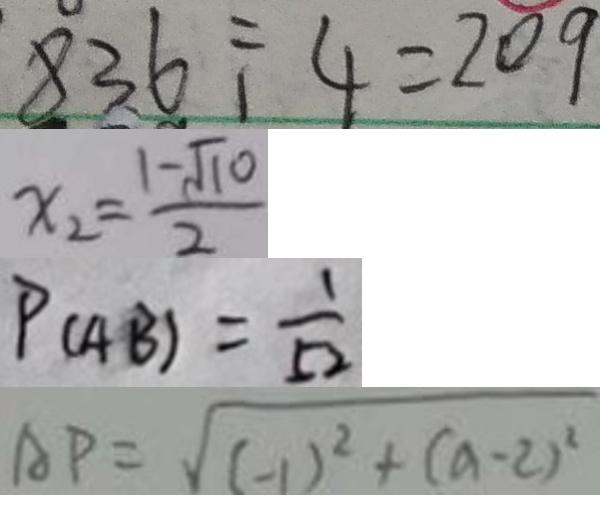Convert formula to latex. <formula><loc_0><loc_0><loc_500><loc_500>8 3 6 \div 4 = 2 0 9 
 x _ { 2 } = \frac { 1 - \sqrt { 1 0 } } { 2 } 
 P ( A B ) = \frac { 1 } { 5 2 } 
 A P = \sqrt { ( - 1 ) ^ { 2 } + ( a - 2 ) ^ { 2 } }</formula> 